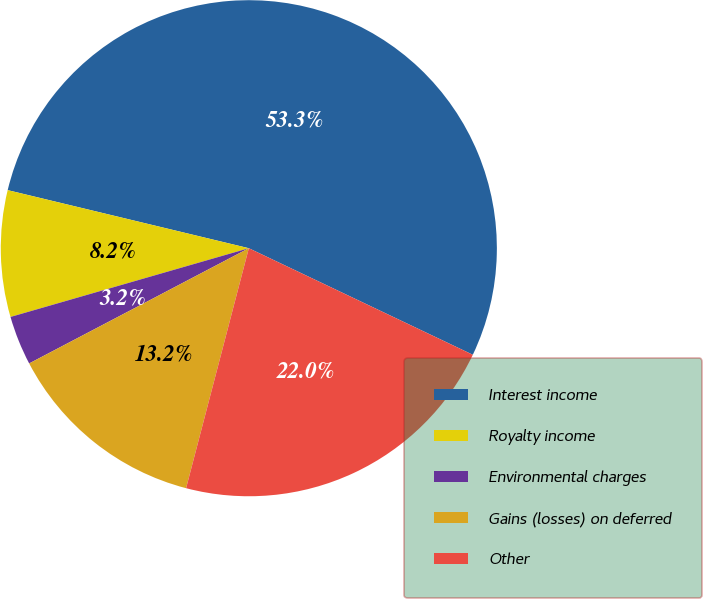Convert chart to OTSL. <chart><loc_0><loc_0><loc_500><loc_500><pie_chart><fcel>Interest income<fcel>Royalty income<fcel>Environmental charges<fcel>Gains (losses) on deferred<fcel>Other<nl><fcel>53.3%<fcel>8.23%<fcel>3.22%<fcel>13.24%<fcel>22.0%<nl></chart> 